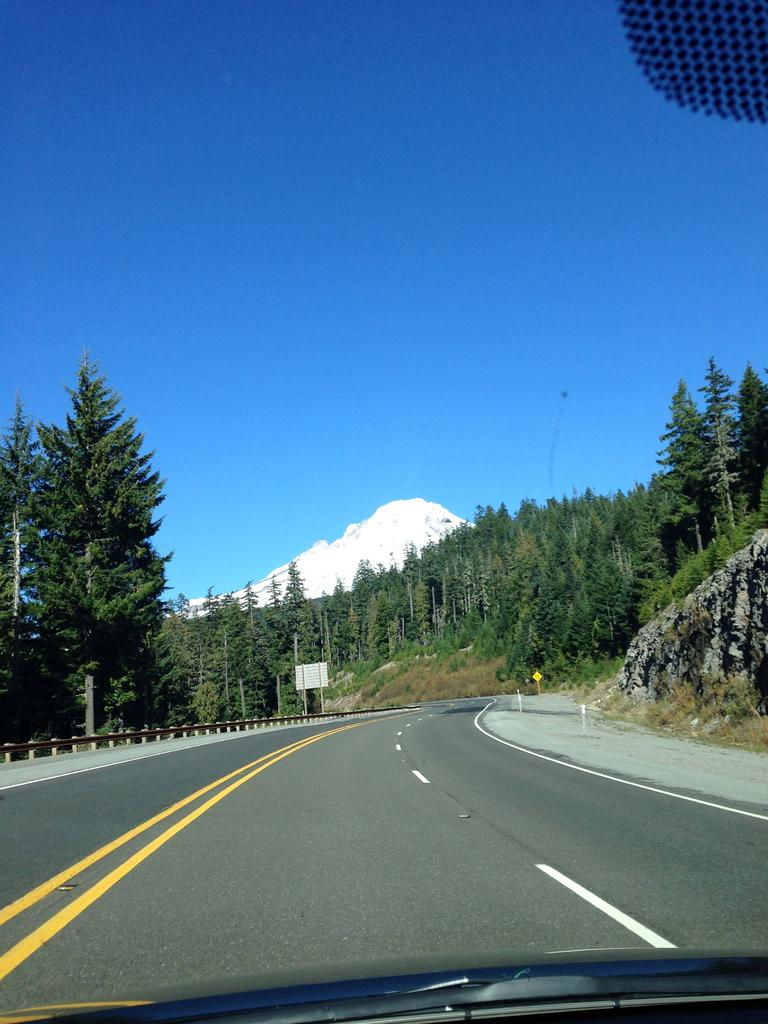What is the main feature of the image? There is a road in the image. What is attached to a pole on the left side of the road? There is a board fixed to a pole on the left side of the road. What type of vegetation can be seen in the image? There are trees in the image. What can be seen in the distance in the background of the image? There is a snow mountain in the background of the image. What is visible above the snow mountain and trees in the image? The sky is visible in the background of the image. What type of drum can be heard playing in the image? There is no drum or sound present in the image; it is a still image of a road, board, trees, snow mountain, and sky. 